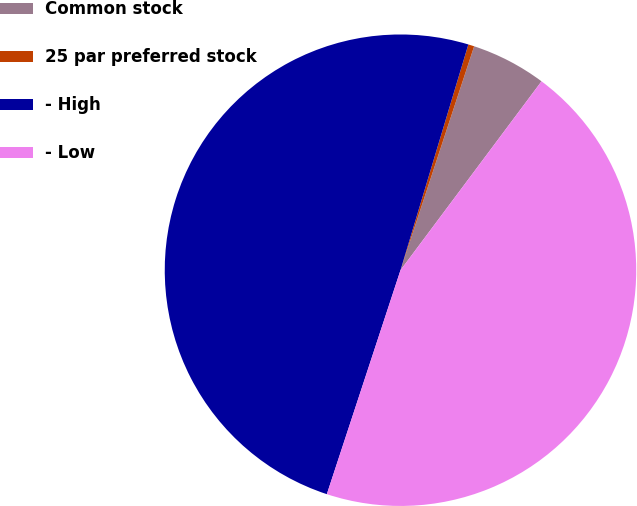<chart> <loc_0><loc_0><loc_500><loc_500><pie_chart><fcel>Common stock<fcel>25 par preferred stock<fcel>- High<fcel>- Low<nl><fcel>5.15%<fcel>0.41%<fcel>49.59%<fcel>44.85%<nl></chart> 